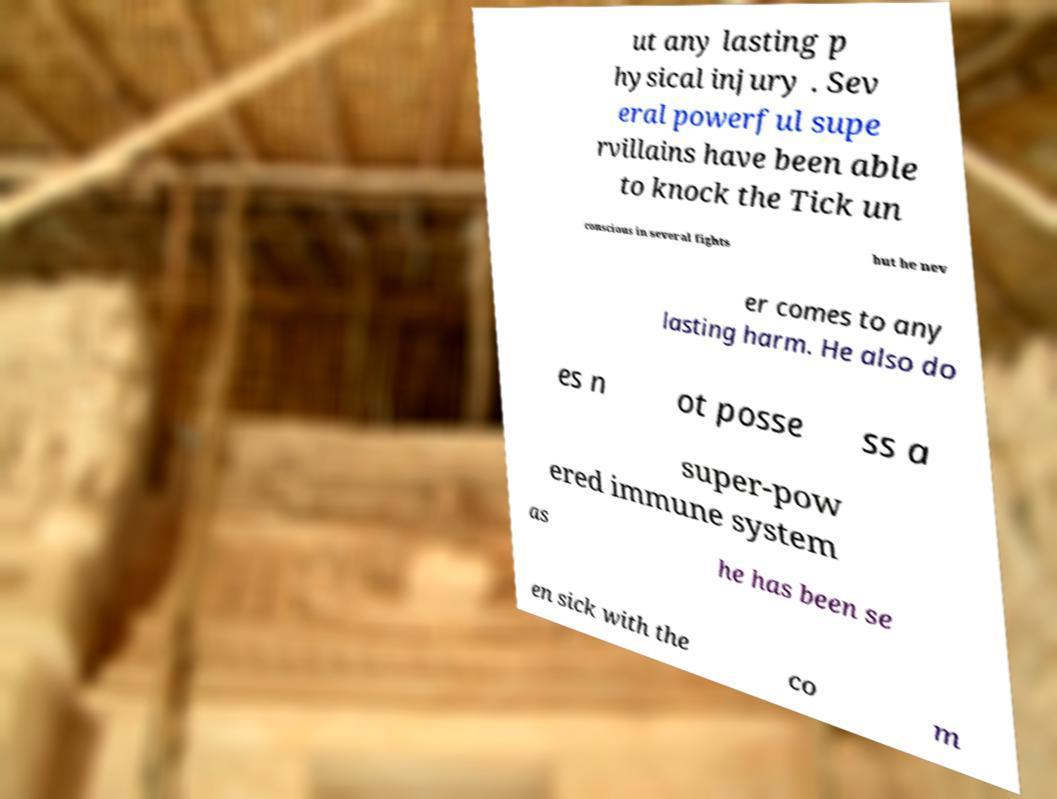Please read and relay the text visible in this image. What does it say? ut any lasting p hysical injury . Sev eral powerful supe rvillains have been able to knock the Tick un conscious in several fights but he nev er comes to any lasting harm. He also do es n ot posse ss a super-pow ered immune system as he has been se en sick with the co m 